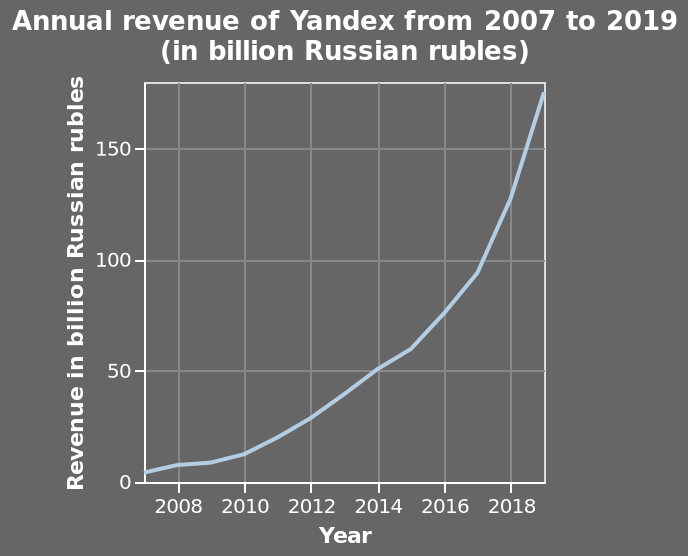<image>
How much did the annual revenue of Yandex increase from 2007 to 2019?  The annual revenue of Yandex showed a steady increase from 5 billion to 75 million Russian rubles between 2007 and 2016, and more than doubled in value from 2016 to 2019. 